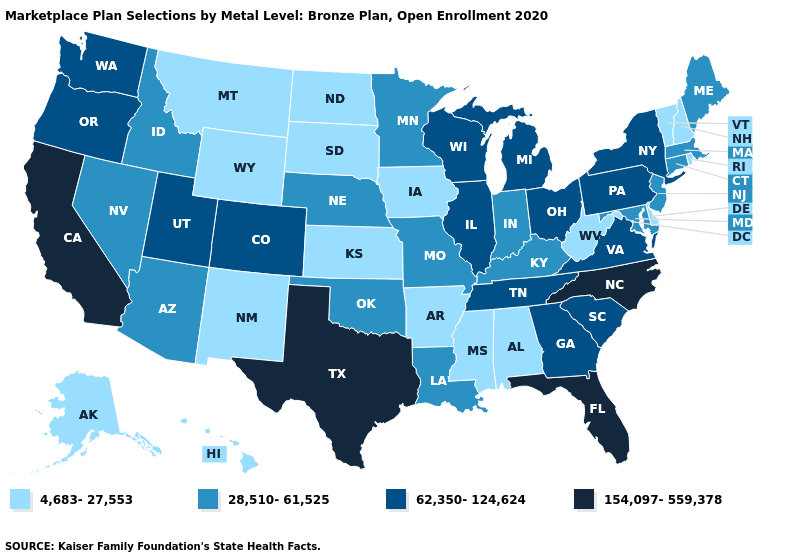What is the value of Wisconsin?
Quick response, please. 62,350-124,624. How many symbols are there in the legend?
Keep it brief. 4. Which states hav the highest value in the Northeast?
Give a very brief answer. New York, Pennsylvania. What is the highest value in the USA?
Keep it brief. 154,097-559,378. What is the value of Texas?
Concise answer only. 154,097-559,378. Which states have the highest value in the USA?
Answer briefly. California, Florida, North Carolina, Texas. Does Nevada have the lowest value in the USA?
Be succinct. No. Among the states that border Connecticut , does Rhode Island have the lowest value?
Give a very brief answer. Yes. Does New York have the same value as Nevada?
Write a very short answer. No. What is the lowest value in states that border New Mexico?
Quick response, please. 28,510-61,525. Among the states that border Texas , does New Mexico have the lowest value?
Answer briefly. Yes. Does the map have missing data?
Quick response, please. No. Which states have the highest value in the USA?
Be succinct. California, Florida, North Carolina, Texas. Which states have the highest value in the USA?
Short answer required. California, Florida, North Carolina, Texas. Among the states that border Wisconsin , which have the lowest value?
Concise answer only. Iowa. 